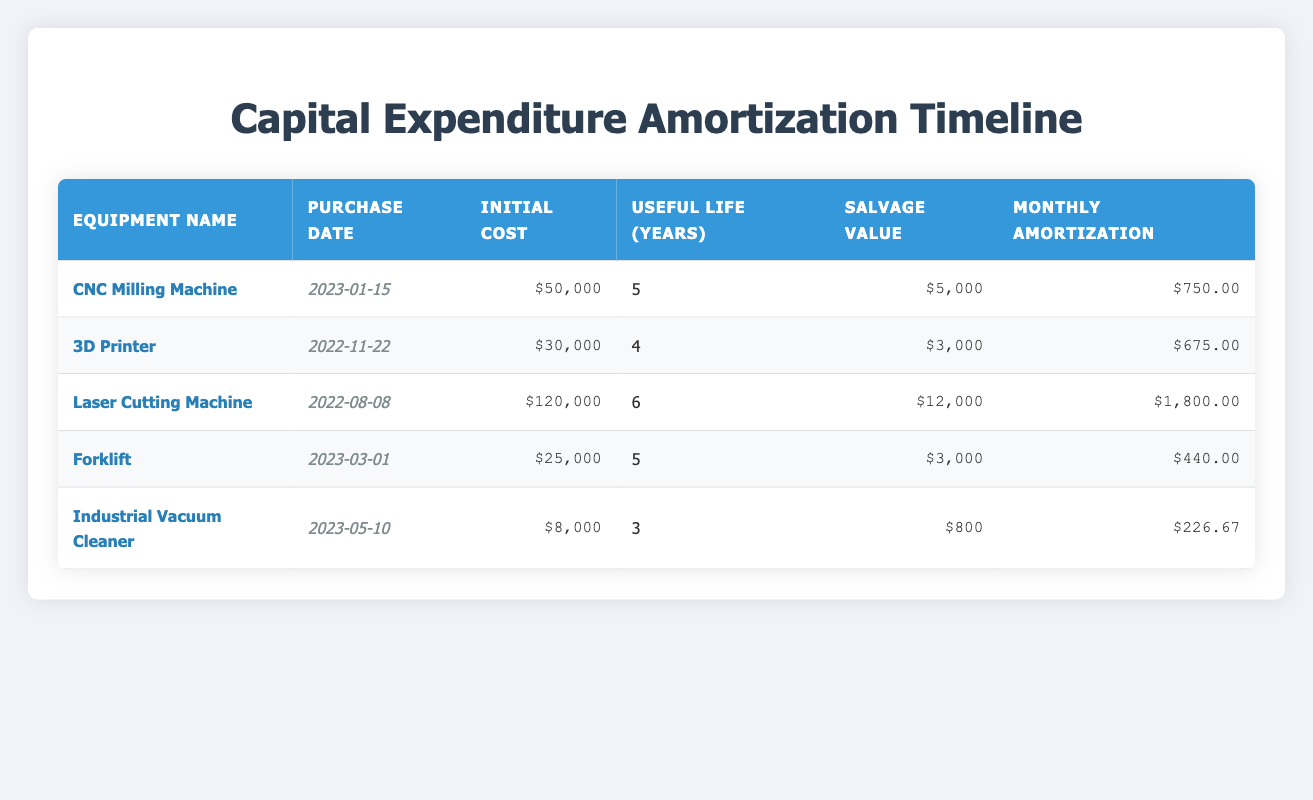What is the initial cost of the Laser Cutting Machine? The initial cost is listed in the table under the "Initial Cost" column for the Laser Cutting Machine. According to the data, the initial cost is $120,000.
Answer: $120,000 What is the monthly amortization for the CNC Milling Machine? The monthly amortization is provided in the table under the "Monthly Amortization" column for the CNC Milling Machine. It states the monthly amortization as $750.
Answer: $750 Which equipment has the longest useful life, and what is that duration? To determine which equipment has the longest useful life, I need to compare the "Useful Life (Years)" values for each item. The longest duration listed is 6 years for the Laser Cutting Machine.
Answer: Laser Cutting Machine, 6 years How much total will be amortized for the 3D Printer over its useful life? To find the total amortization for the 3D Printer, I multiply the monthly amortization by the total number of months in the equipment's useful life (4 years = 48 months). The monthly amortization is $675, so the total is 675 x 48 = $32,400.
Answer: $32,400 Is the salvage value of the Industrial Vacuum Cleaner greater than its monthly amortization? I need to compare the salvage value and the monthly amortization of the Industrial Vacuum Cleaner. The salvage value is $800, and the monthly amortization is $226.67. Since $800 is greater than $226.67, the statement is true.
Answer: Yes What is the total initial cost of all the equipment purchased? To find the total initial cost, I sum the initial costs listed in the table: 50000 (CNC) + 30000 (3D Printer) + 120000 (Laser) + 25000 (Forklift) + 8000 (Vacuum) = $228,000.
Answer: $228,000 How much will be saved from the total initial costs if the salvage values of all equipment are considered? First, I sum the salvage values: 5000 (CNC) + 3000 (3D) + 12000 (Laser) + 3000 (Forklift) + 800 (Vacuum) = $22,800. Then, I subtract this from the total initial cost ($228,000 - $22,800) to get $205,200.
Answer: $205,200 Has any equipment been purchased in the year 2023? I can check the "Purchase Date" column for any equipment purchased in 2023. The CNC Milling Machine, Forklift, and Industrial Vacuum Cleaner were all purchased in 2023, so the answer is true.
Answer: Yes Which equipment has a monthly amortization less than $500? From the "Monthly Amortization" column, I review all equipment's values. The only equipment with a monthly amortization less than $500 is the Forklift ($440) and the Industrial Vacuum Cleaner ($226.67).
Answer: Forklift, Industrial Vacuum Cleaner 